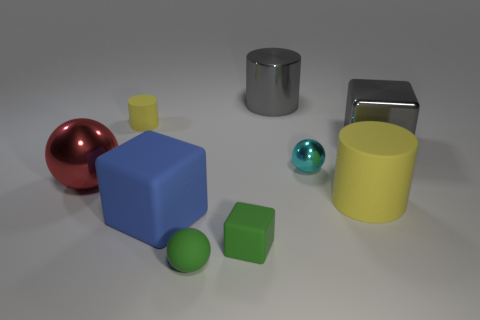Subtract all yellow cylinders. How many were subtracted if there are1yellow cylinders left? 1 Add 1 gray metallic cubes. How many objects exist? 10 Subtract all spheres. How many objects are left? 6 Add 5 big yellow matte cylinders. How many big yellow matte cylinders exist? 6 Subtract 0 blue balls. How many objects are left? 9 Subtract all blue metallic blocks. Subtract all rubber blocks. How many objects are left? 7 Add 1 small cylinders. How many small cylinders are left? 2 